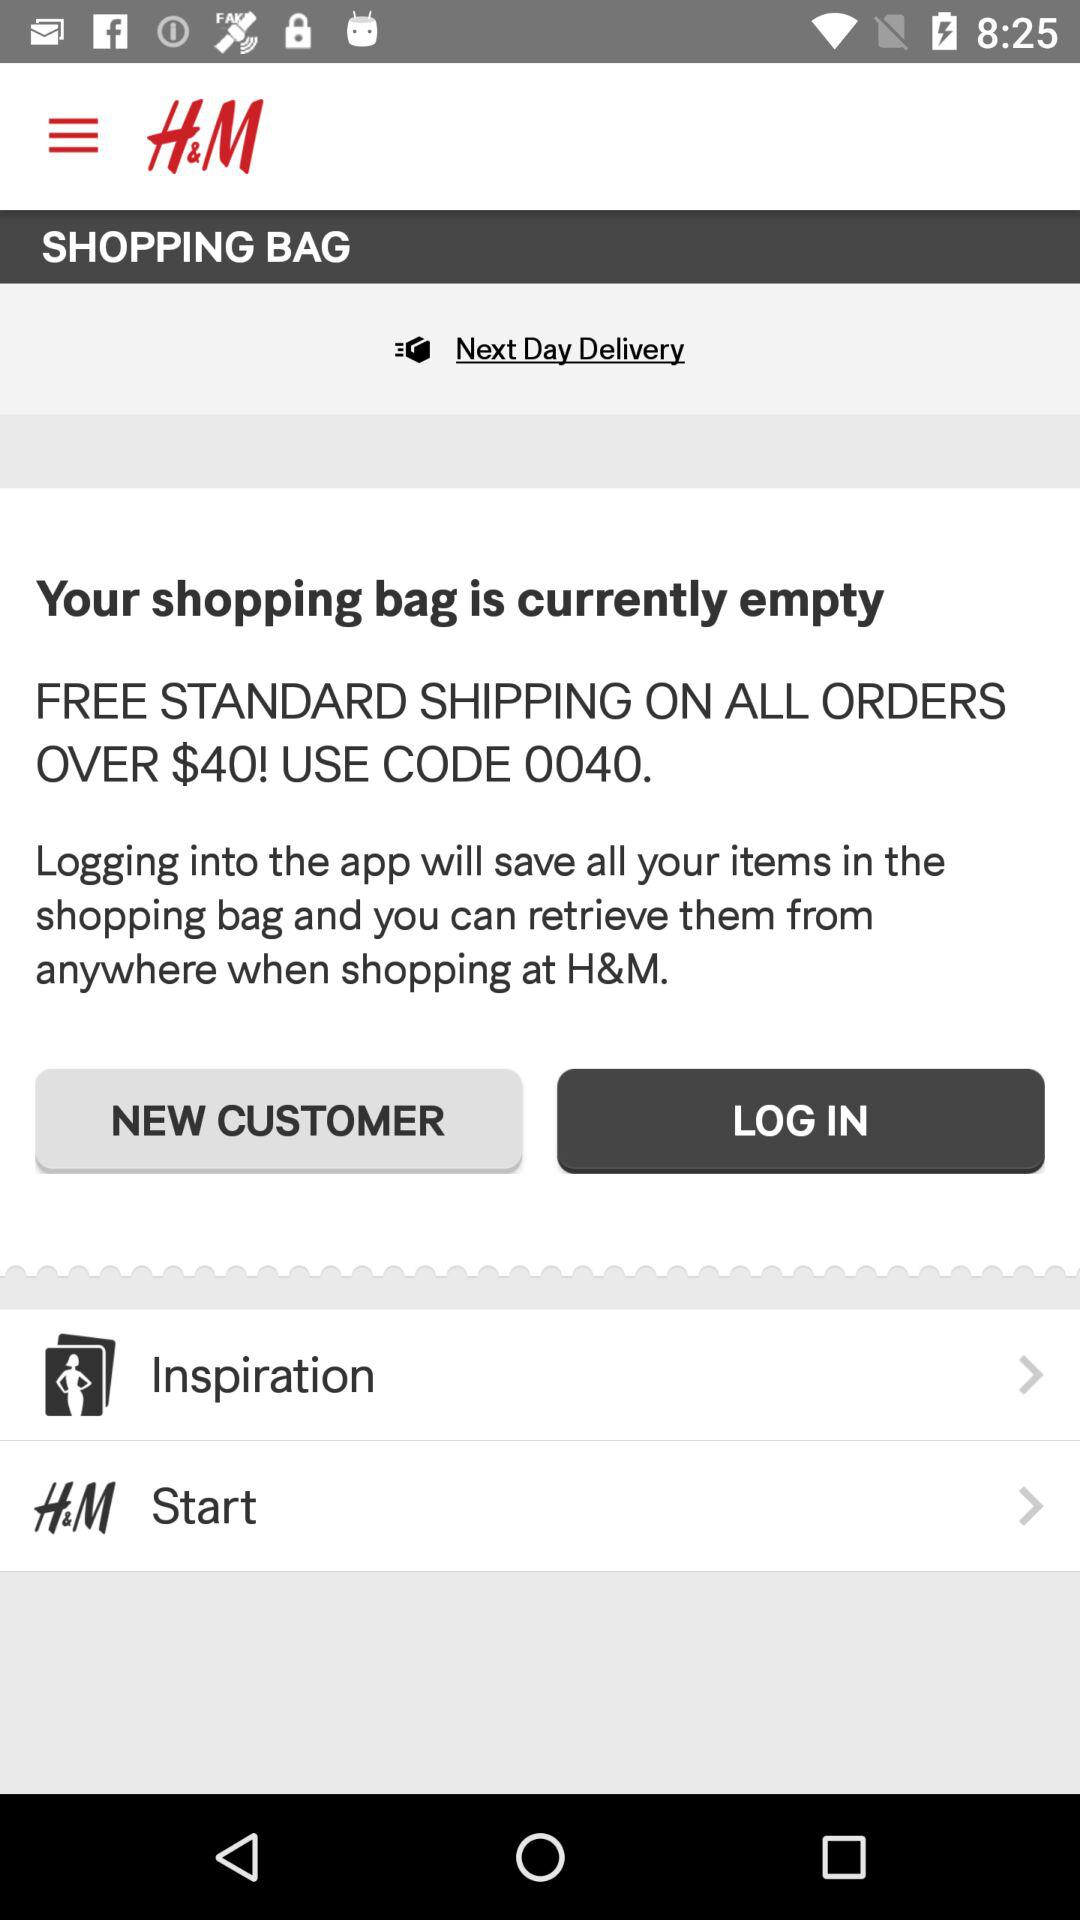How many items are in the shopping bag? The shopping bag is empty. 